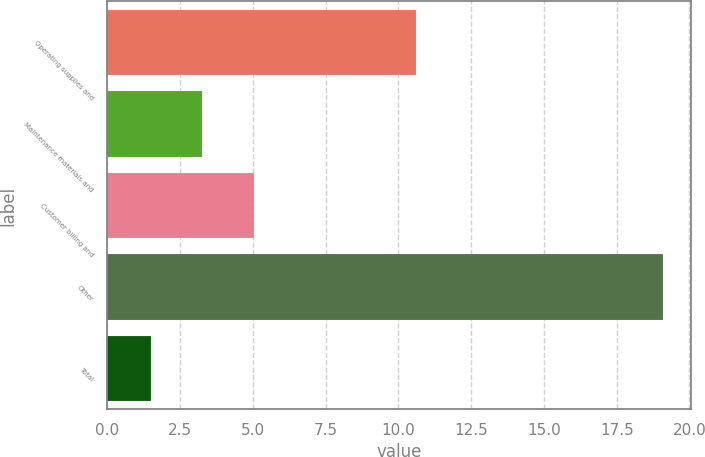Convert chart. <chart><loc_0><loc_0><loc_500><loc_500><bar_chart><fcel>Operating supplies and<fcel>Maintenance materials and<fcel>Customer billing and<fcel>Other<fcel>Total<nl><fcel>10.6<fcel>3.26<fcel>5.02<fcel>19.1<fcel>1.5<nl></chart> 